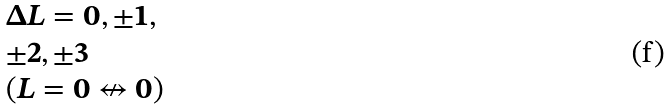<formula> <loc_0><loc_0><loc_500><loc_500>\begin{array} { l } { \Delta L = 0 , \pm 1 , } \\ { \pm 2 , \pm 3 } \\ { ( L = 0 \not \leftrightarrow 0 ) } \end{array}</formula> 